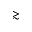<formula> <loc_0><loc_0><loc_500><loc_500>\gtrsim</formula> 